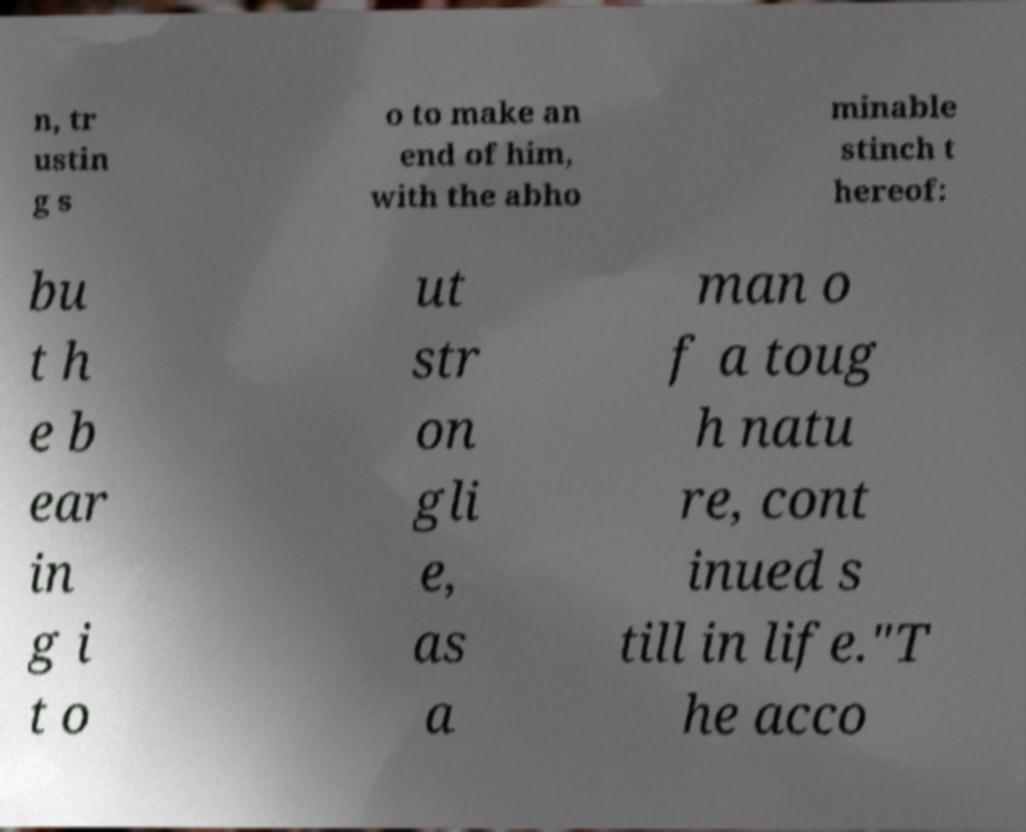Please identify and transcribe the text found in this image. n, tr ustin g s o to make an end of him, with the abho minable stinch t hereof: bu t h e b ear in g i t o ut str on gli e, as a man o f a toug h natu re, cont inued s till in life."T he acco 